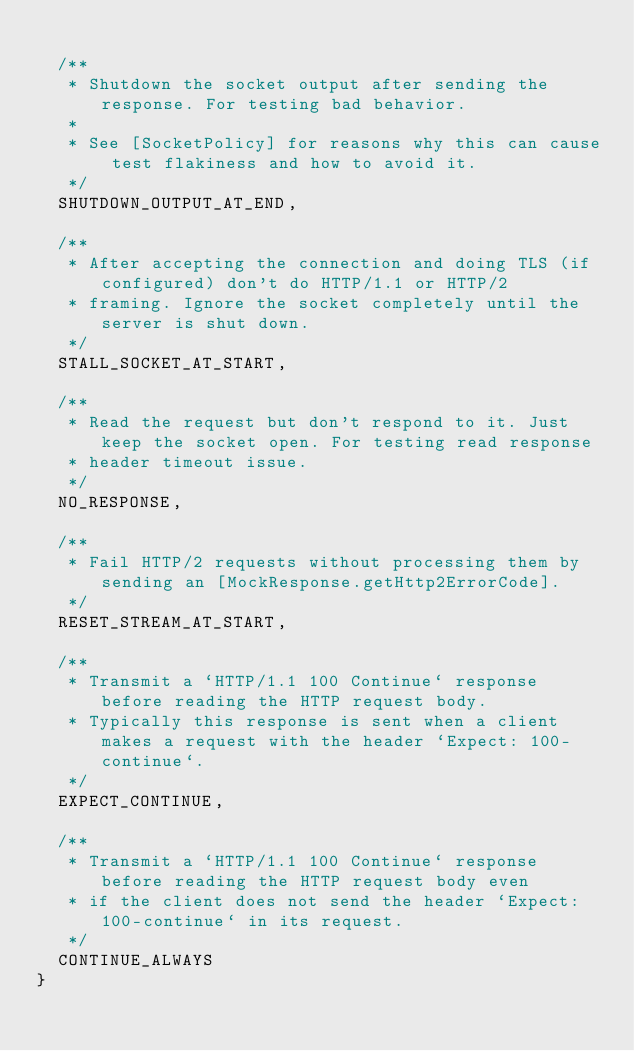<code> <loc_0><loc_0><loc_500><loc_500><_Kotlin_>
  /**
   * Shutdown the socket output after sending the response. For testing bad behavior.
   *
   * See [SocketPolicy] for reasons why this can cause test flakiness and how to avoid it.
   */
  SHUTDOWN_OUTPUT_AT_END,

  /**
   * After accepting the connection and doing TLS (if configured) don't do HTTP/1.1 or HTTP/2
   * framing. Ignore the socket completely until the server is shut down.
   */
  STALL_SOCKET_AT_START,

  /**
   * Read the request but don't respond to it. Just keep the socket open. For testing read response
   * header timeout issue.
   */
  NO_RESPONSE,

  /**
   * Fail HTTP/2 requests without processing them by sending an [MockResponse.getHttp2ErrorCode].
   */
  RESET_STREAM_AT_START,

  /**
   * Transmit a `HTTP/1.1 100 Continue` response before reading the HTTP request body.
   * Typically this response is sent when a client makes a request with the header `Expect: 100-continue`.
   */
  EXPECT_CONTINUE,

  /**
   * Transmit a `HTTP/1.1 100 Continue` response before reading the HTTP request body even
   * if the client does not send the header `Expect: 100-continue` in its request.
   */
  CONTINUE_ALWAYS
}
</code> 